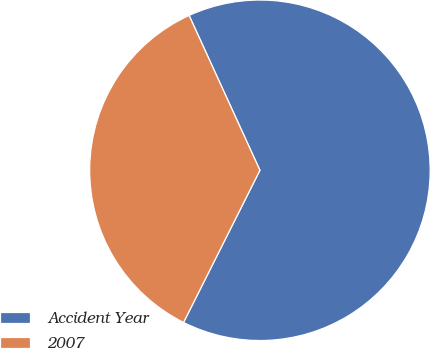Convert chart. <chart><loc_0><loc_0><loc_500><loc_500><pie_chart><fcel>Accident Year<fcel>2007<nl><fcel>64.23%<fcel>35.77%<nl></chart> 